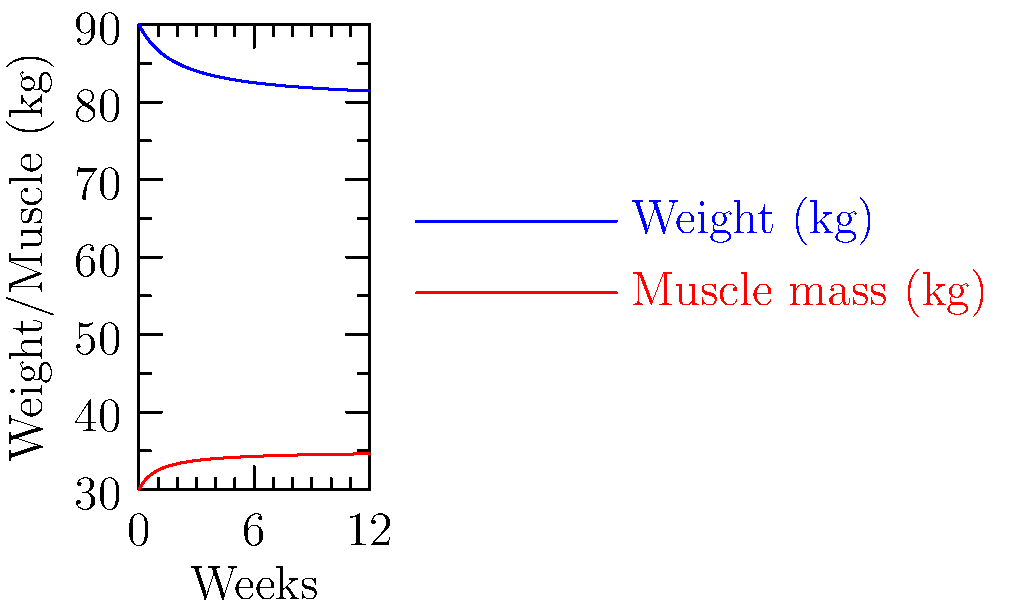Based on the graph showing a client's weight loss and muscle gain over 12 weeks, at approximately which week does the client's muscle mass reach 33 kg? To solve this problem, we need to follow these steps:

1. Identify the red line as the muscle mass graph.
2. Locate the 33 kg mark on the y-axis.
3. Find where the red line intersects with the 33 kg horizontal line.
4. Trace this point to the x-axis to determine the corresponding week.

Looking at the graph:
1. The red line represents muscle mass.
2. The 33 kg mark is between 30 and 35 on the y-axis.
3. The red line crosses the 33 kg point approximately 1/3 of the way between week 4 and week 8.
4. This corresponds to about week 5-6.

To be more precise, we can estimate that the intersection occurs closer to week 6 than week 5.
Answer: Week 6 